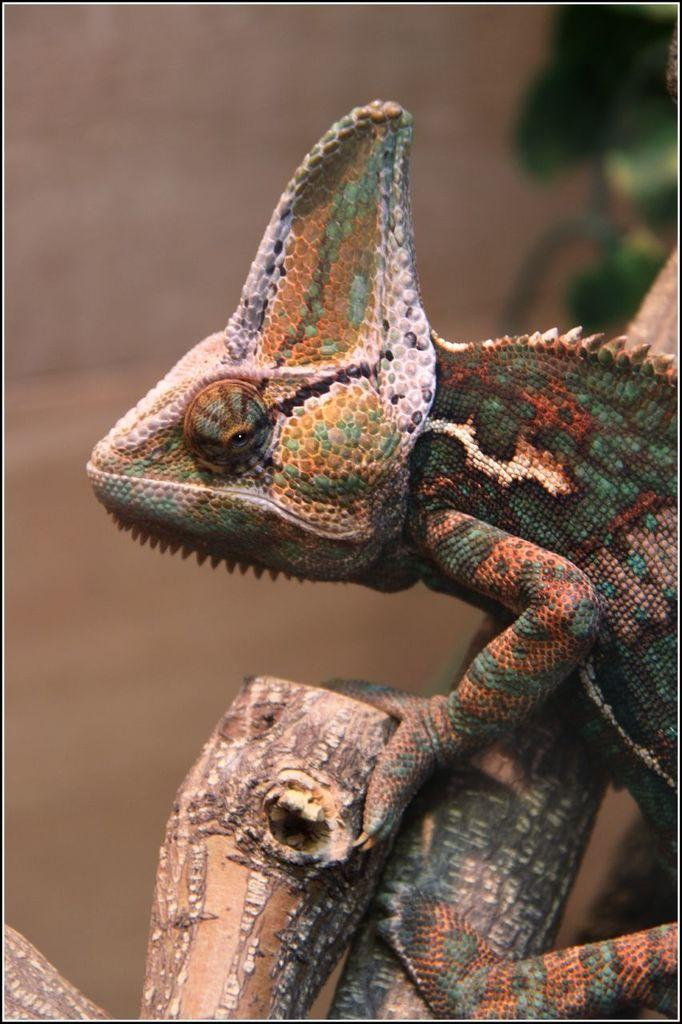What type of animal is in the picture? There is a colorful lizard in the picture. Where is the lizard located? The lizard is sitting on a tree branch. Can you describe the background of the image? The background of the image is blurred. What type of representative is shown in the image? There is no representative present in the image; it features a colorful lizard sitting on a tree branch. How many oranges can be seen in the image? There are no oranges present in the image. 